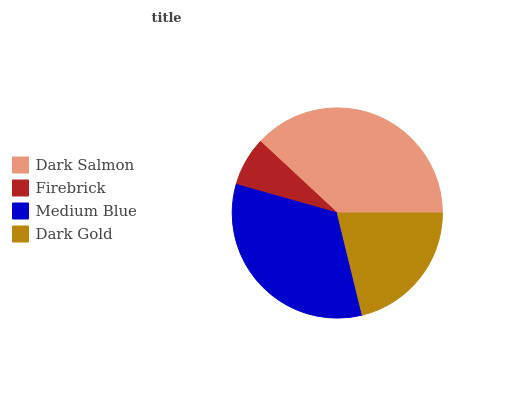Is Firebrick the minimum?
Answer yes or no. Yes. Is Dark Salmon the maximum?
Answer yes or no. Yes. Is Medium Blue the minimum?
Answer yes or no. No. Is Medium Blue the maximum?
Answer yes or no. No. Is Medium Blue greater than Firebrick?
Answer yes or no. Yes. Is Firebrick less than Medium Blue?
Answer yes or no. Yes. Is Firebrick greater than Medium Blue?
Answer yes or no. No. Is Medium Blue less than Firebrick?
Answer yes or no. No. Is Medium Blue the high median?
Answer yes or no. Yes. Is Dark Gold the low median?
Answer yes or no. Yes. Is Dark Salmon the high median?
Answer yes or no. No. Is Firebrick the low median?
Answer yes or no. No. 